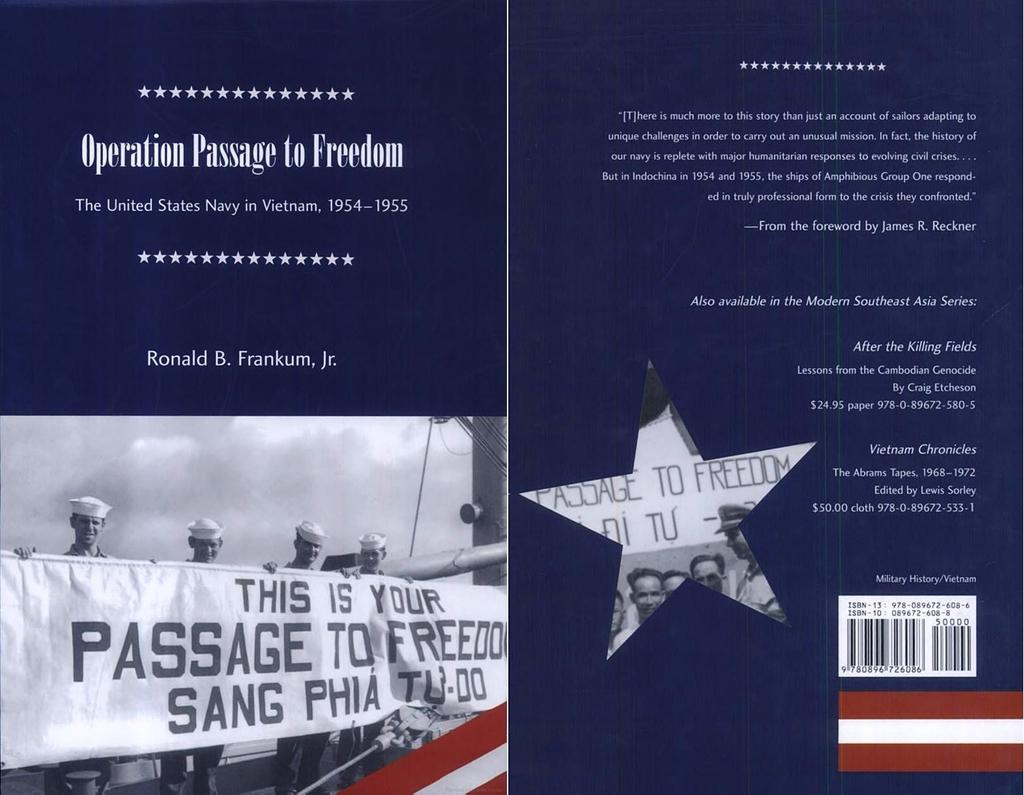Where was this image taken?
Ensure brevity in your answer.  Vietnam. What is the title on the top left page?
Provide a succinct answer. Operation passage to freedom. 